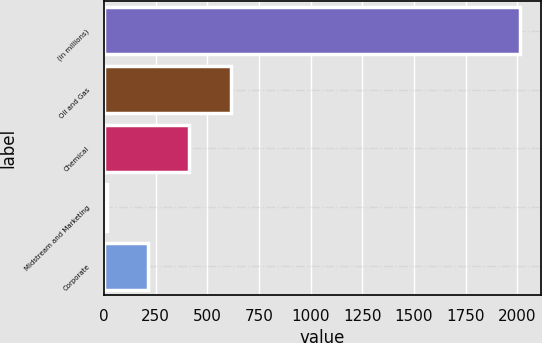<chart> <loc_0><loc_0><loc_500><loc_500><bar_chart><fcel>(in millions)<fcel>Oil and Gas<fcel>Chemical<fcel>Midstream and Marketing<fcel>Corporate<nl><fcel>2013<fcel>613<fcel>413<fcel>13<fcel>213<nl></chart> 